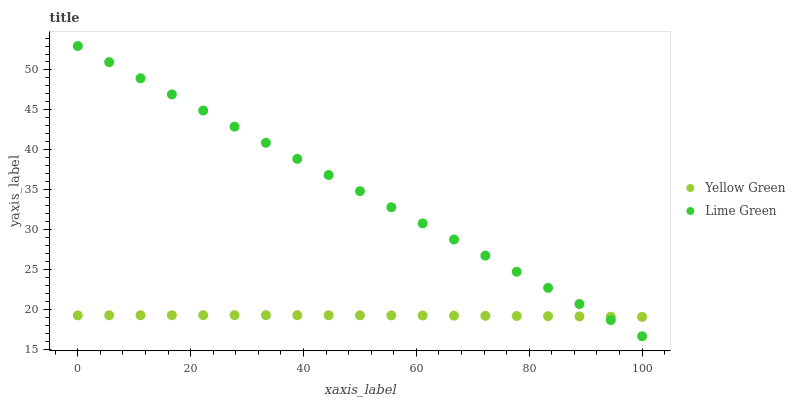Does Yellow Green have the minimum area under the curve?
Answer yes or no. Yes. Does Lime Green have the maximum area under the curve?
Answer yes or no. Yes. Does Yellow Green have the maximum area under the curve?
Answer yes or no. No. Is Lime Green the smoothest?
Answer yes or no. Yes. Is Yellow Green the roughest?
Answer yes or no. Yes. Is Yellow Green the smoothest?
Answer yes or no. No. Does Lime Green have the lowest value?
Answer yes or no. Yes. Does Yellow Green have the lowest value?
Answer yes or no. No. Does Lime Green have the highest value?
Answer yes or no. Yes. Does Yellow Green have the highest value?
Answer yes or no. No. Does Yellow Green intersect Lime Green?
Answer yes or no. Yes. Is Yellow Green less than Lime Green?
Answer yes or no. No. Is Yellow Green greater than Lime Green?
Answer yes or no. No. 